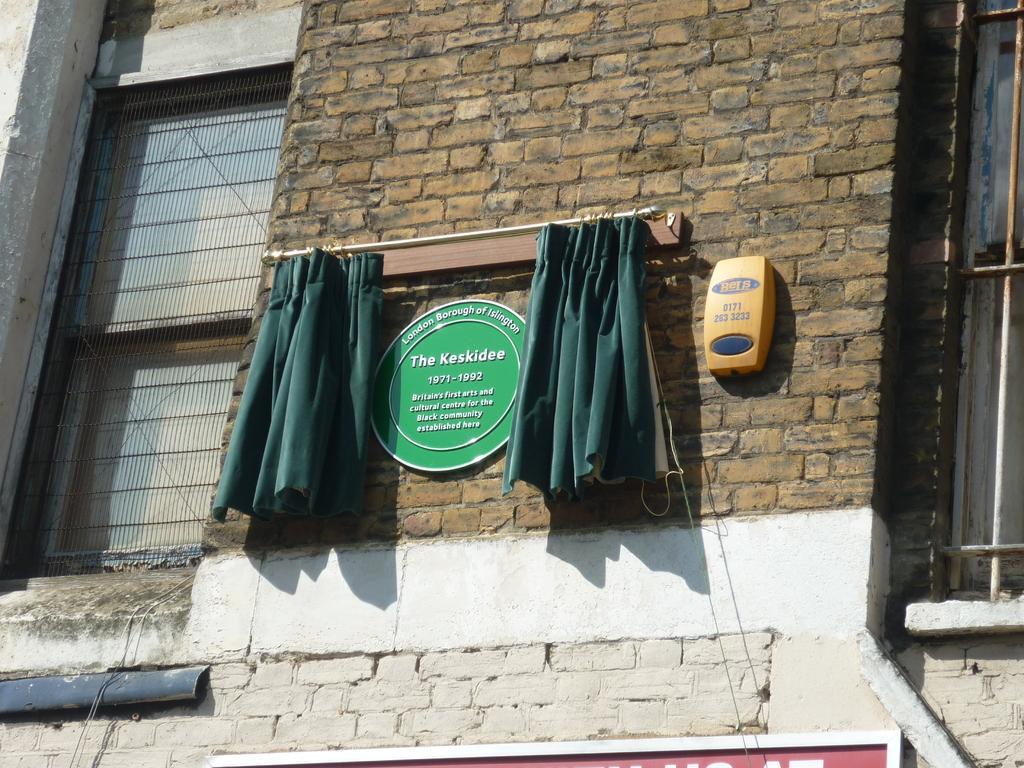Could you give a brief overview of what you see in this image? In this picture we can see the building wall with brown color bricks. On the top there is a green color naming logo and small green curtains. Beside there is a yellow box and on both the side there is a window grills. 